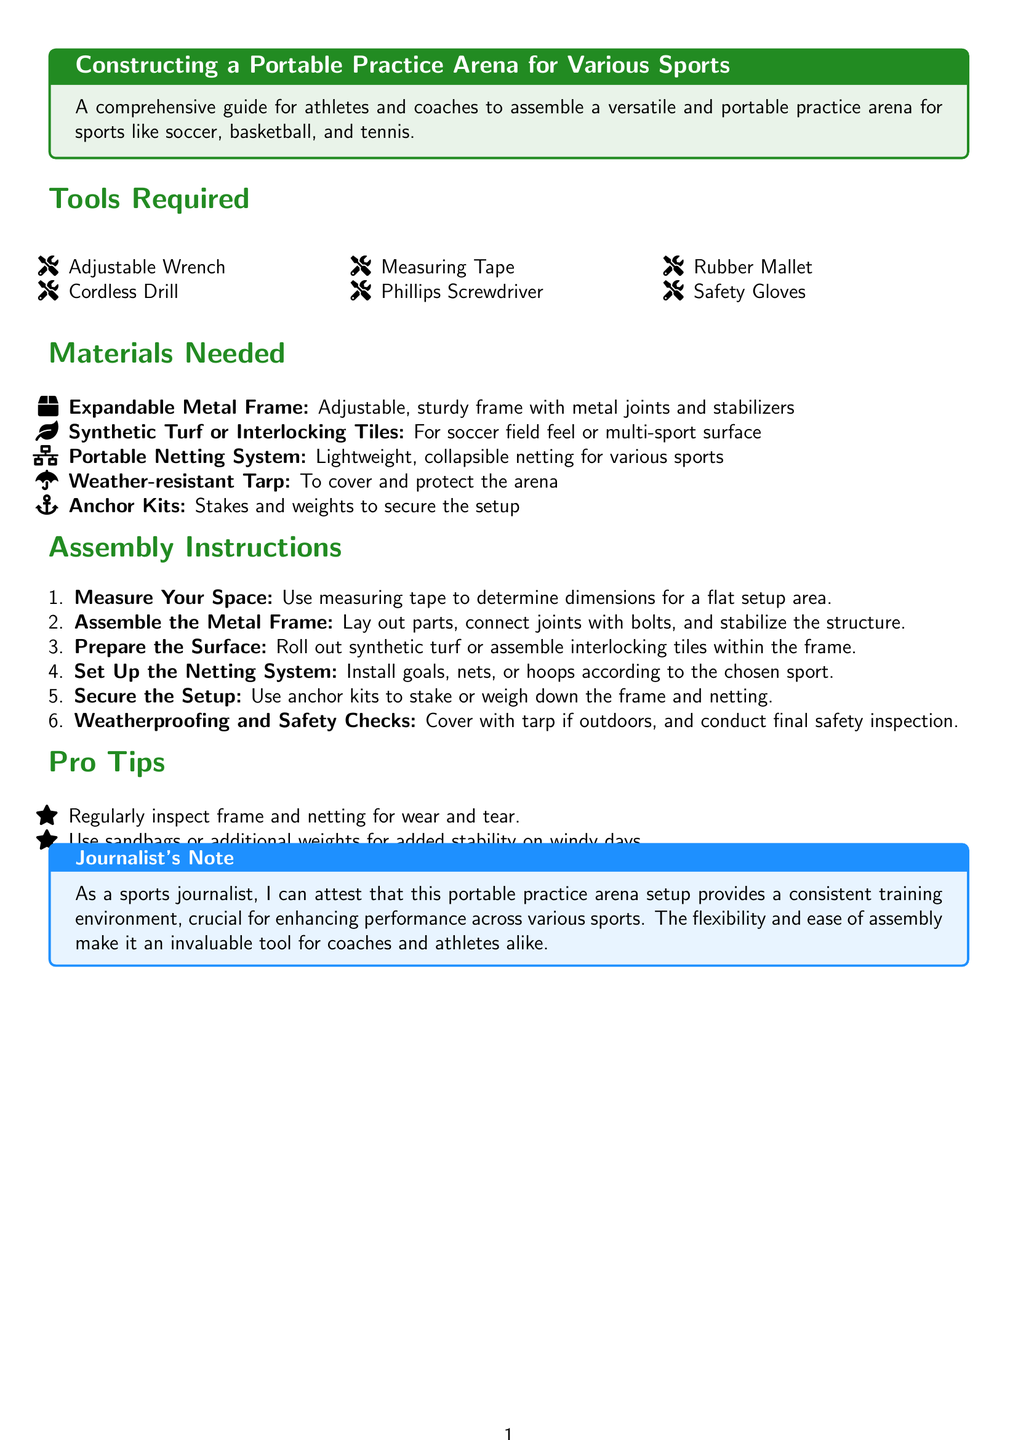What is the title of the document? The title is stated in the tcolorbox at the beginning of the document.
Answer: Constructing a Portable Practice Arena for Various Sports How many tools are required? The number of tools is indicated in the "Tools Required" section.
Answer: Six What is the first item listed in the materials needed? The first item is the first material mentioned in the materials section.
Answer: Expandable Metal Frame What is used for securing the setup? This is found in the "Secure the Setup" instruction within the assembly instructions.
Answer: Anchor Kits What is the last step in the assembly instructions? The last step is the final instruction provided in the assembly section.
Answer: Weatherproofing and Safety Checks What is the color of the "Journalist's Note" box? The color of the box is mentioned in the section title.
Answer: Sport blue What is one of the pro tips for stability? This is outlined in the "Pro Tips" section.
Answer: Use sandbags or additional weights How should the surface be prepared? This is detailed in step three of the assembly instructions.
Answer: Roll out synthetic turf or assemble interlocking tiles What is the purpose of the weather-resistant tarp? The purpose is mentioned during the assembly instructions.
Answer: To cover and protect the arena 